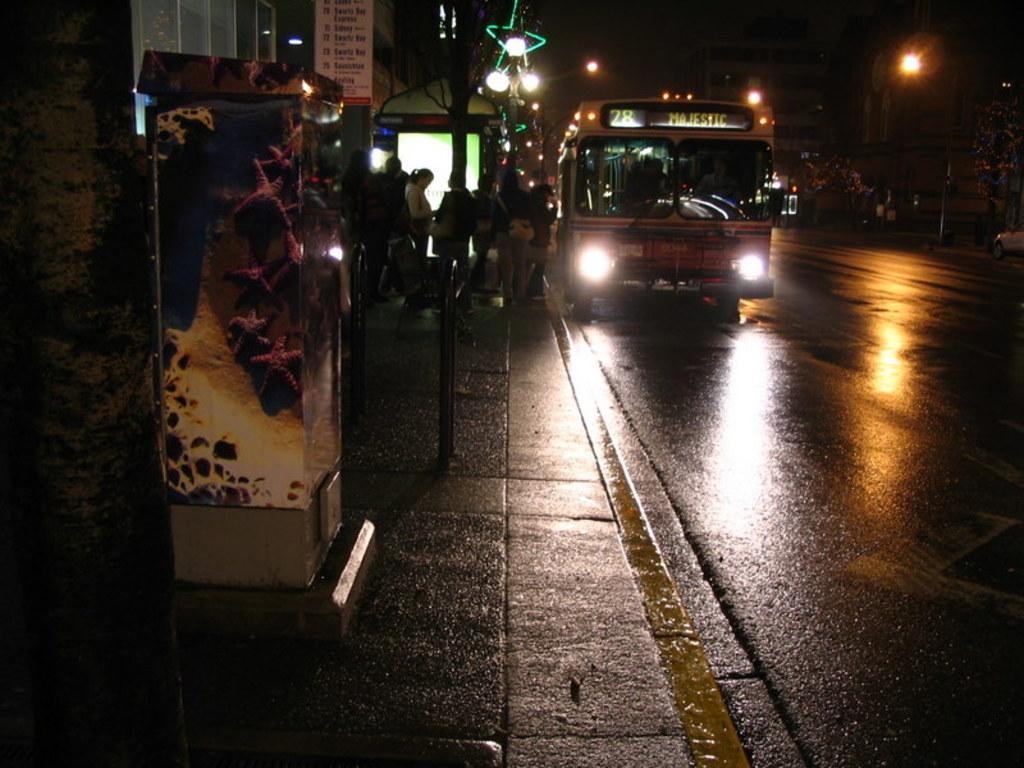What type of vehicle is on the road in the image? There is a bus on the road in the image. What are the people in the image doing? There is a group of people standing in the image. What structures can be seen in the image? There are buildings visible in the image. What type of vegetation is present in the image? Trees are present in the image. What type of illumination is visible in the image? There are lights in the image. What is visible in the background of the image? The sky is visible in the image. Can you tell me how many experts are present in the wilderness in the image? There are no experts or wilderness present in the image. What type of self-reflection can be seen in the image? There is no self-reflection or any indication of self-reflection in the image. 